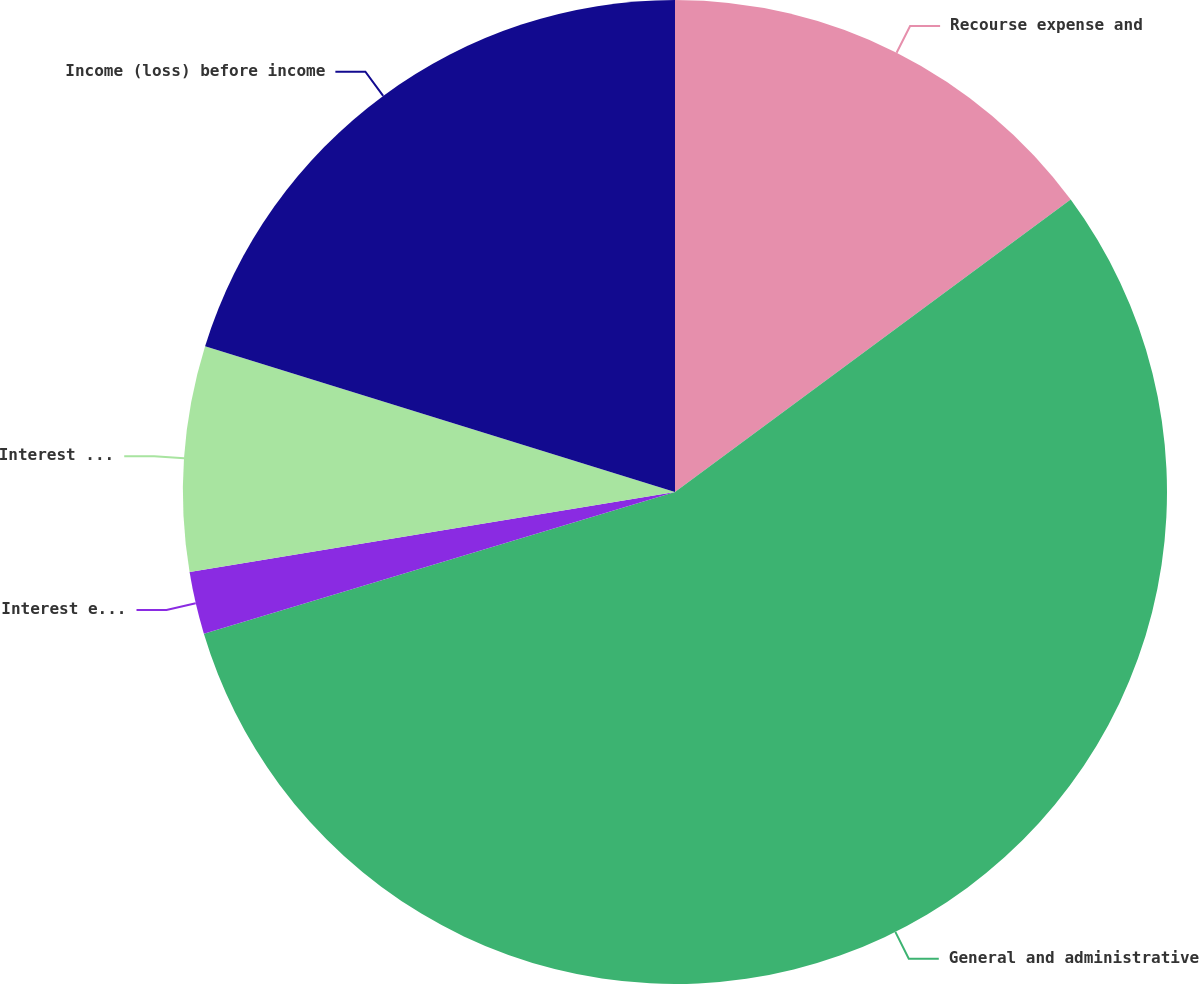<chart> <loc_0><loc_0><loc_500><loc_500><pie_chart><fcel>Recourse expense and<fcel>General and administrative<fcel>Interest expense<fcel>Interest and other (income)<fcel>Income (loss) before income<nl><fcel>14.87%<fcel>55.47%<fcel>2.05%<fcel>7.39%<fcel>20.21%<nl></chart> 